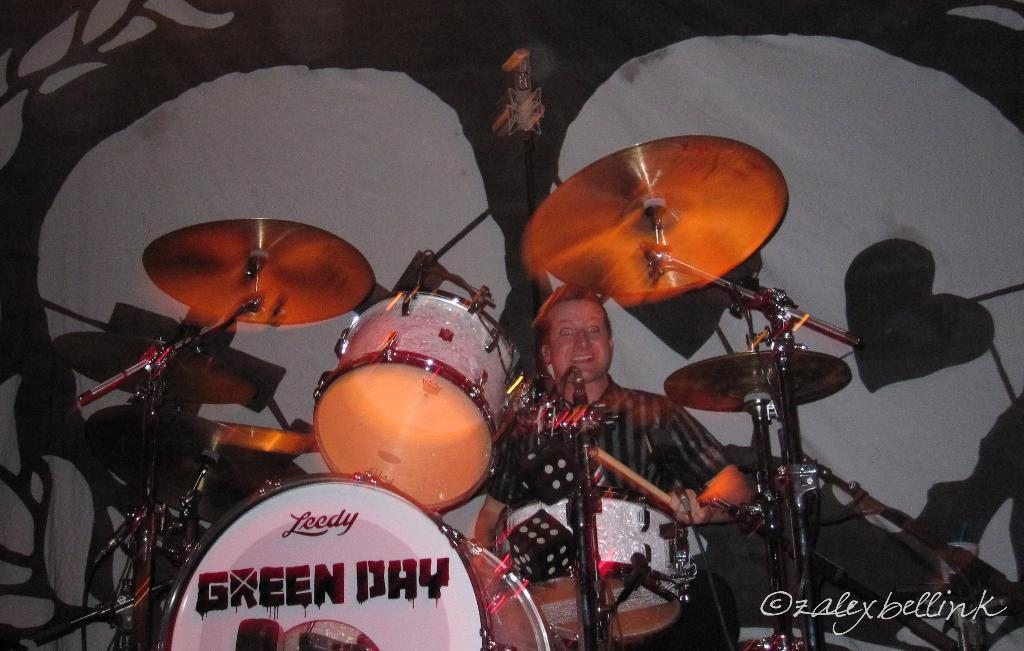What is the person in the image doing? There is a person sitting in the image. What musical instruments are present in the image? There are drums and cymbals with cymbal stands in the image. What can be seen in the background of the image? There is a cloth in the background of the image. Is there any additional information about the image itself? Yes, there is a watermark on the image. What type of cracker is being used as a drumstick in the image? There is no cracker being used as a drumstick in the image; the person is likely using drumsticks or their hands to play the drums. 